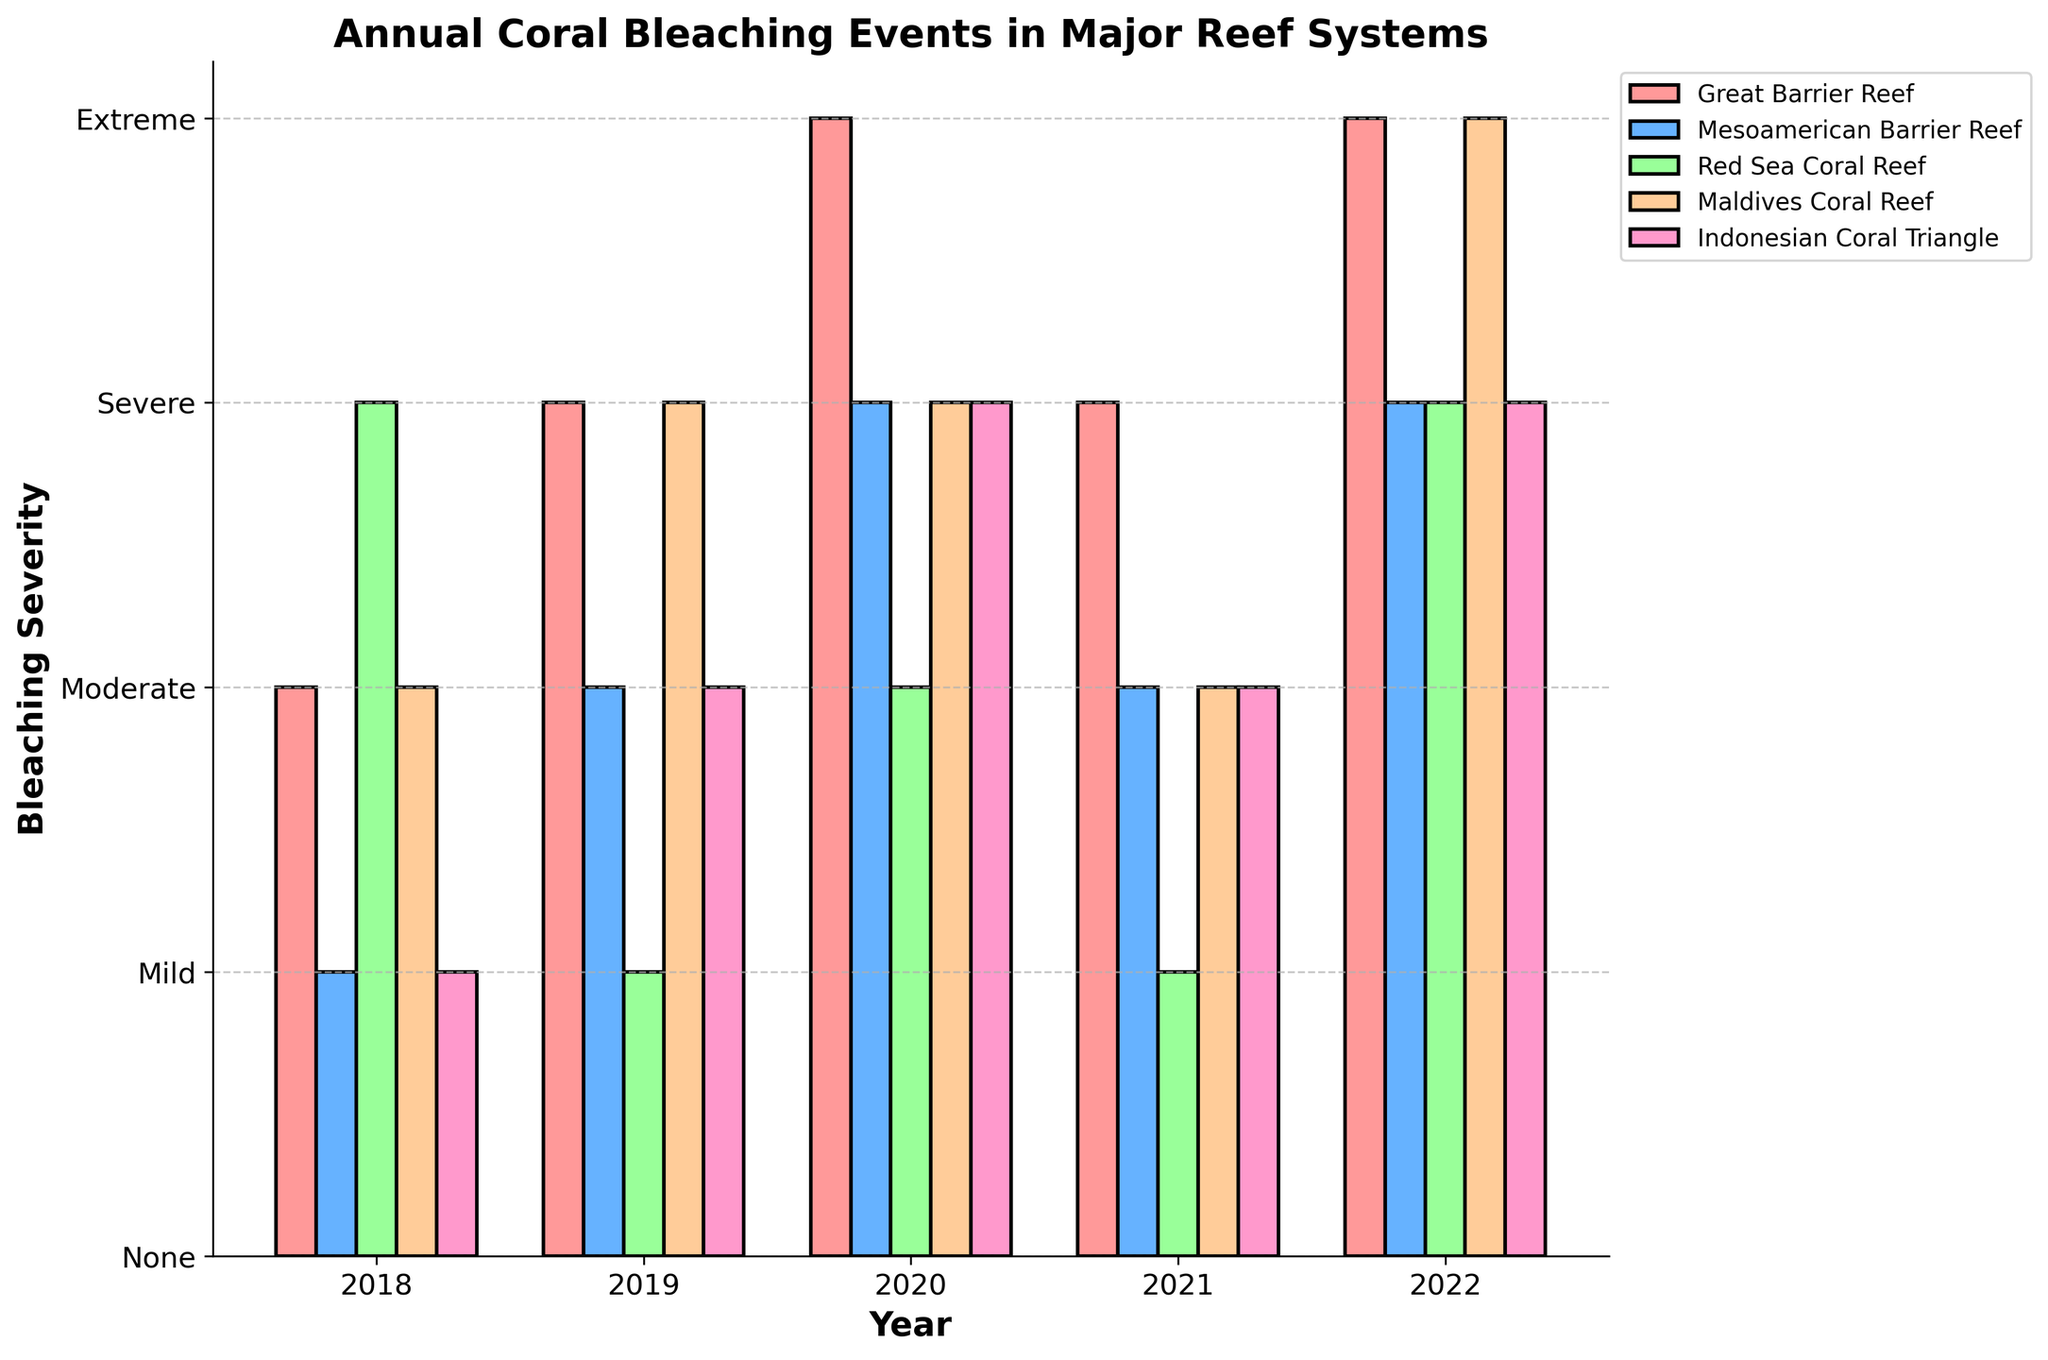Which reef system had the most "Extreme" bleaching events over the years? We look at the "Extreme" category across all reef systems over the given years and count occurrences. The counts are: Great Barrier: 2, Mesoamerican: 0, Red Sea: 1, Maldives: 1, Indonesian: 0. Therefore, Great Barrier Reef had the most "Extreme" events.
Answer: Great Barrier Reef In which year did the majority of reef systems experience "Severe" bleaching? We observe the severity in each year and count how many times each severity level appears. In 2022, Great Barrier, Mesoamerican, Red Sea, and Indonesian coral reefs all experienced "Severe" bleaching.
Answer: 2022 How does the Great Barrier Reef's bleaching severity in 2020 compare to the Maldives Coral Reef in 2020? For 2020, we see that the Great Barrier Reef had "Extreme" bleaching while the Maldives Coral Reef also had "Severe" bleaching. Comparing the severity levels, "Extreme" is higher than "Severe".
Answer: Great Barrier Reef is more severe What is the average bleaching severity for the Indonesian Coral Triangle over the years? Severity map: Mild=1, Moderate=2, Severe=3, Extreme=4. Indonesian Coral Triangle severities: Mild(1), Moderate(2), Severe(3), Severe(3), Severe(3). Average = (1+2+3+3+3)/5 = 2.4
Answer: 2.4 Which year had the highest average bleaching severity across all reef systems? Convert each severity level to its numeric equivalent and then average them per year. 2020 has the highest severity levels: (4+3+2+3+3)/5 = 3
Answer: 2020 What is the trend of bleaching severity in the Great Barrier Reef from 2018 to 2022? The severities are: Moderate(2018), Severe(2019), Extreme(2020), Severe(2021), Extreme(2022). The trend alternates between Severe and Extreme, with no mild years.
Answer: Alternating Severe and Extreme Which reef system had the least "Severe" bleaching events? Count the occurrences of "Severe" for each system: Great Barrier: 2, Mesoamerican: 2, Red Sea: 2, Maldives: 2, Indonesian: 3. All except Indonesian Coral Triangle had 2 "Severe" events.
Answer: Mesoamerican, Red Sea and Maldives (each with 2) 